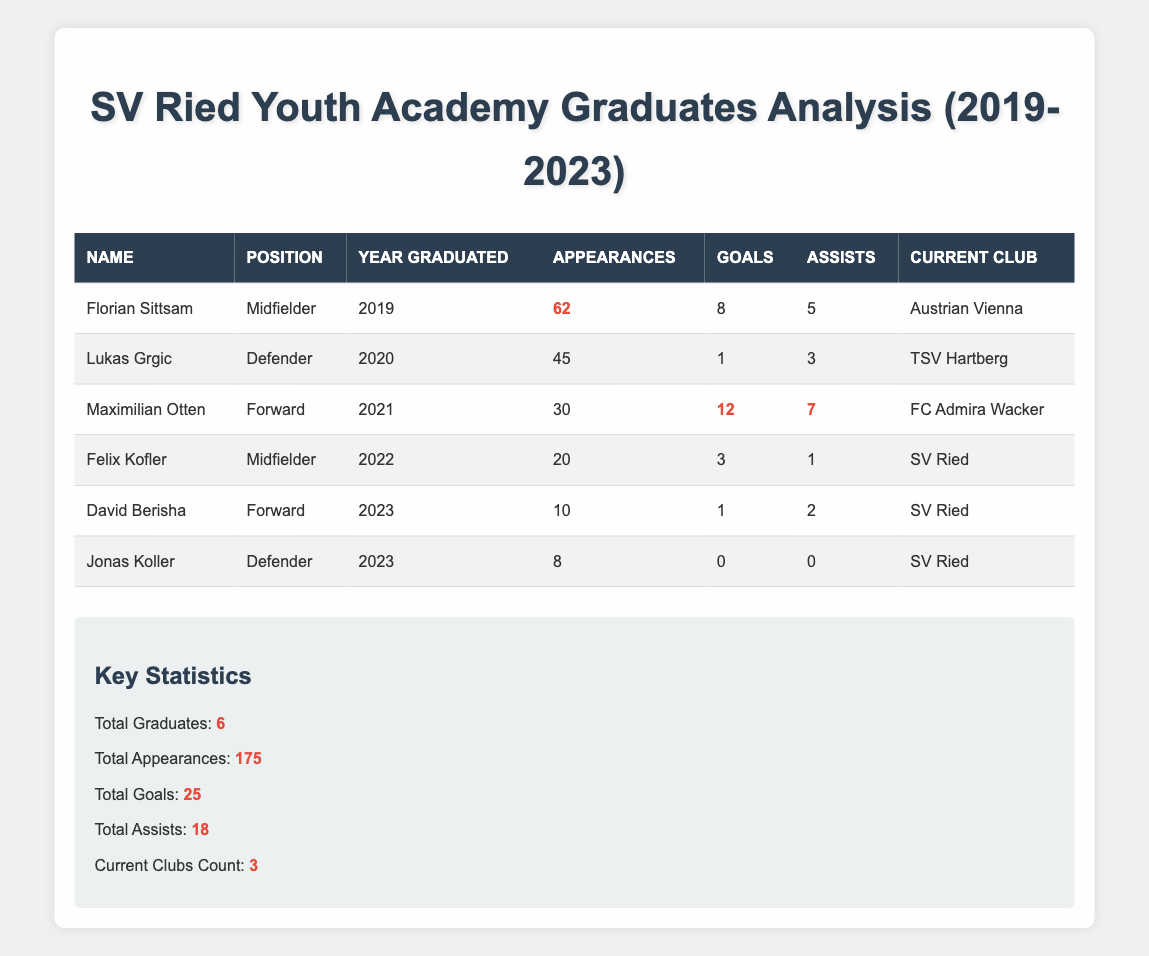What is the total number of goals scored by all graduates? To find the total number of goals, we need to add the goals scored by each graduate: 8 (Sittsam) + 1 (Grgic) + 12 (Otten) + 3 (Kofler) + 1 (Berisha) + 0 (Koller) = 25.
Answer: 25 Who has the highest number of appearances among the graduates? By checking the appearances for each graduate, Florian Sittsam has 62 appearances, which is the highest compared to the others.
Answer: Florian Sittsam How many graduates are currently playing for SV Ried? Looking at the current clubs of the graduates, both Felix Kofler and David Berisha are currently playing for SV Ried. Thus, there are 2 graduates in SV Ried.
Answer: 2 What was the average number of assists per graduate? We sum the assists: 5 (Sittsam) + 3 (Grgic) + 7 (Otten) + 1 (Kofler) + 2 (Berisha) + 0 (Koller) = 18. Then, we divide by the number of graduates: 18 / 6 = 3.
Answer: 3 Is it true that Maximilian Otten has more goals than Felix Kofler? Maximilian Otten has scored 12 goals, while Felix Kofler has scored 3 goals. Since 12 is greater than 3, the statement is true.
Answer: Yes What is the difference in the number of appearances between the graduate with the most appearances and the one with the least? The graduate with the most appearances is Florian Sittsam with 62, and the one with the least is Jonas Koller with 8. The difference is 62 - 8 = 54.
Answer: 54 Which year had the graduate with the most goals? Maximilian Otten graduated in 2021 and scored 12 goals, which is more than any other graduate. Thus, 2021 is the year with the highest goals by a graduate.
Answer: 2021 How many total clubs do the graduates currently represent? The current clubs listed for the graduates are Austrian Vienna, TSV Hartberg, FC Admira Wacker, and SV Ried, making a total of 3 distinct current clubs.
Answer: 3 What percentage of total appearances do the graduates from 2023 contribute? The total appearances from 2023 graduates (David Berisha and Jonas Koller) is 10 + 8 = 18. The total appearances of all graduates is 175. The percentage is (18 / 175) * 100 = 10.29%.
Answer: 10.29% What is the total number of assists from forwards in the last 5 years? The forwards are Maximilian Otten, David Berisha, and their assists are: 7 (Otten) + 2 (Berisha) = 9.
Answer: 9 